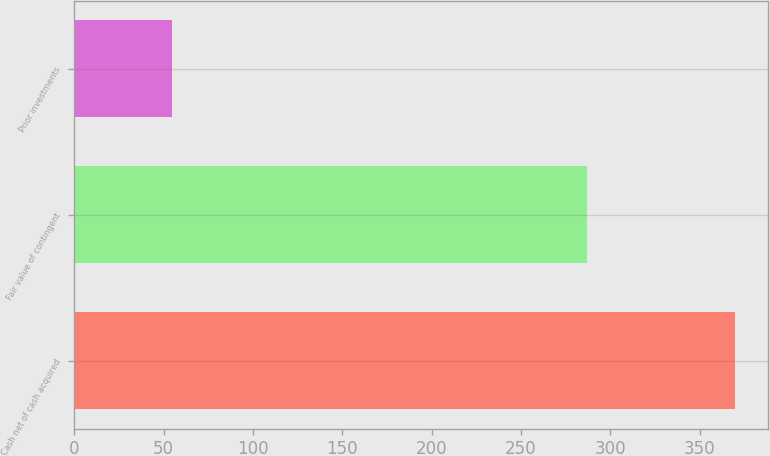<chart> <loc_0><loc_0><loc_500><loc_500><bar_chart><fcel>Cash net of cash acquired<fcel>Fair value of contingent<fcel>Prior investments<nl><fcel>370<fcel>287<fcel>55<nl></chart> 